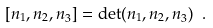<formula> <loc_0><loc_0><loc_500><loc_500>[ { n _ { 1 } , n _ { 2 } , n } _ { 3 } ] = \det ( { n _ { 1 } , n _ { 2 } , n } _ { 3 } ) \ .</formula> 